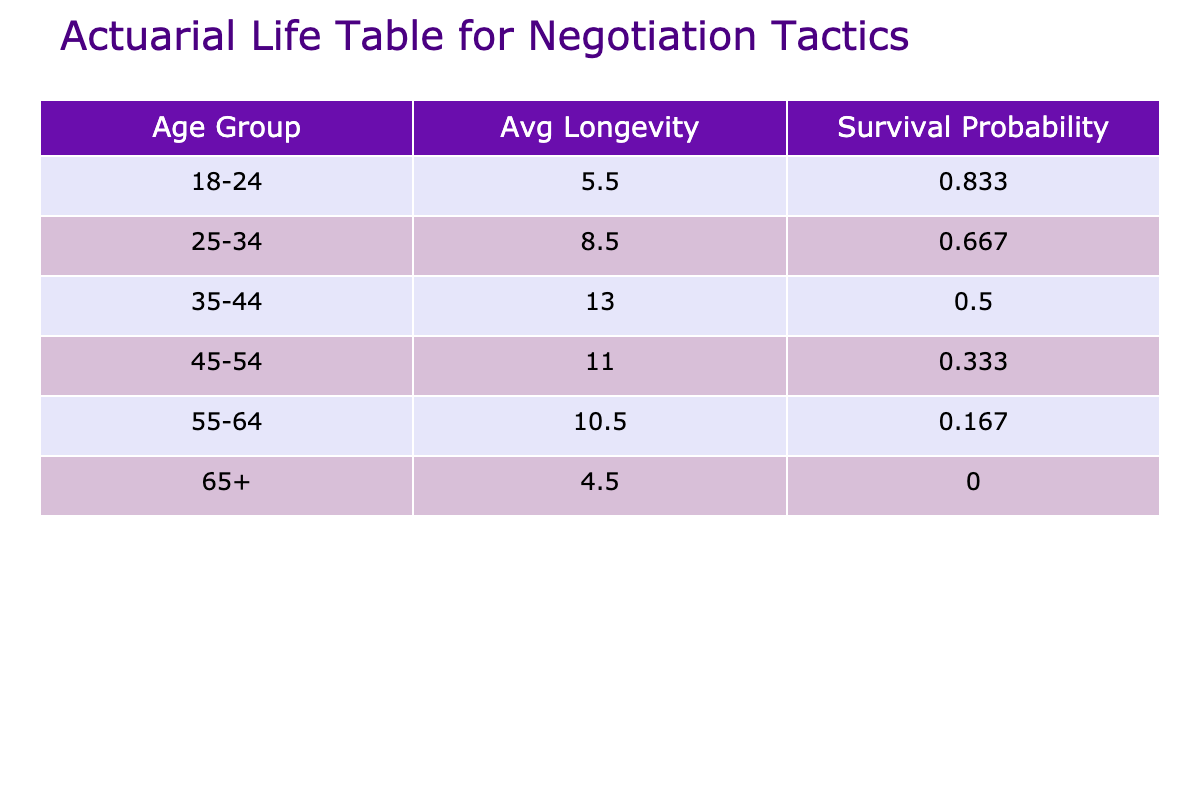What is the average negotiation tactic longevity for individuals aged 35-44? To find the average longevity for the age group 35-44, we look at the values in the table: 15 (France), 11 (Nigeria), and 14 (Italy). Adding these: 15 + 11 + 14 = 40, and there are three entries, so we divide 40 by 3 to get an average longevity of approximately 13.3 years.
Answer: 13.3 Which country has the highest negotiation tactic longevity for individuals with a Doctorate? The Doctorate educational background entries are: 15 (France) and 14 (Italy). Comparing these values, France has the highest longevity of 15 years.
Answer: France Is the cultural negotiation style for the South Korean age group collaborative? In the table, the cultural negotiation style for South Korea under the age group 18-24 is listed as Hierarchical, not Collaborative. Therefore, the statement is false.
Answer: False What is the survival probability for the age group 55-64? From the table, the survival probabilities are given in sequence. The age groups considered (18-24, 25-34, 35-44, 45-54, 55-64) show a survival probability of 0.667 for the 55-64 age group.
Answer: 0.667 How does the average negotiation tactic longevity for Germany compare to that of Brazil? The average longevity for Germany (Bachelor's Degree, 8 years) and Brazil (High School, 4 years) can be compared directly. Germany has 8 years and Brazil has 4 years, making Germany's longevity 4 years longer than Brazil's.
Answer: Germany is 4 years longer than Brazil What is the total negotiation tactic longevity for all individuals aged 65 and older? The negotiations tactic longevity for individuals aged 65 and older is: 4 (Brazil) and 5 (Mexico). Adding these values gives 4 + 5 = 9 years in total for this age group.
Answer: 9 Which educational background is associated with the highest average negotiation tactic longevity? We can consider the averages: Bachelor's Degree (5 + 8 + 6 + 9 = 28 for 4 entries gives 7), Master’s Degree (10 + 12 + 11 + 5 = 38 for 4 entries gives 9.5), and Doctorate (15 + 14 = 29 for 2 entries gives 14.5). The Doctorate has the highest average longevity of 14.5 years.
Answer: Doctorate Does the data show a tendency for higher negotiation tactic longevity with advanced educational backgrounds? Yes, examining the entries, we can observe that individuals with Master's (average 9.5 years) and Doctorate (14.5 years) backgrounds tend to have longer pragmatic negotiation tactics compared to those with Bachelor's (7 years) and High School (5 years).
Answer: Yes 